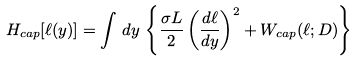<formula> <loc_0><loc_0><loc_500><loc_500>H _ { c a p } [ \ell ( y ) ] = \int \, d y \, \left \{ \frac { \sigma L } { 2 } \left ( \frac { d \ell } { d y } \right ) ^ { 2 } + W _ { c a p } ( \ell ; D ) \right \}</formula> 